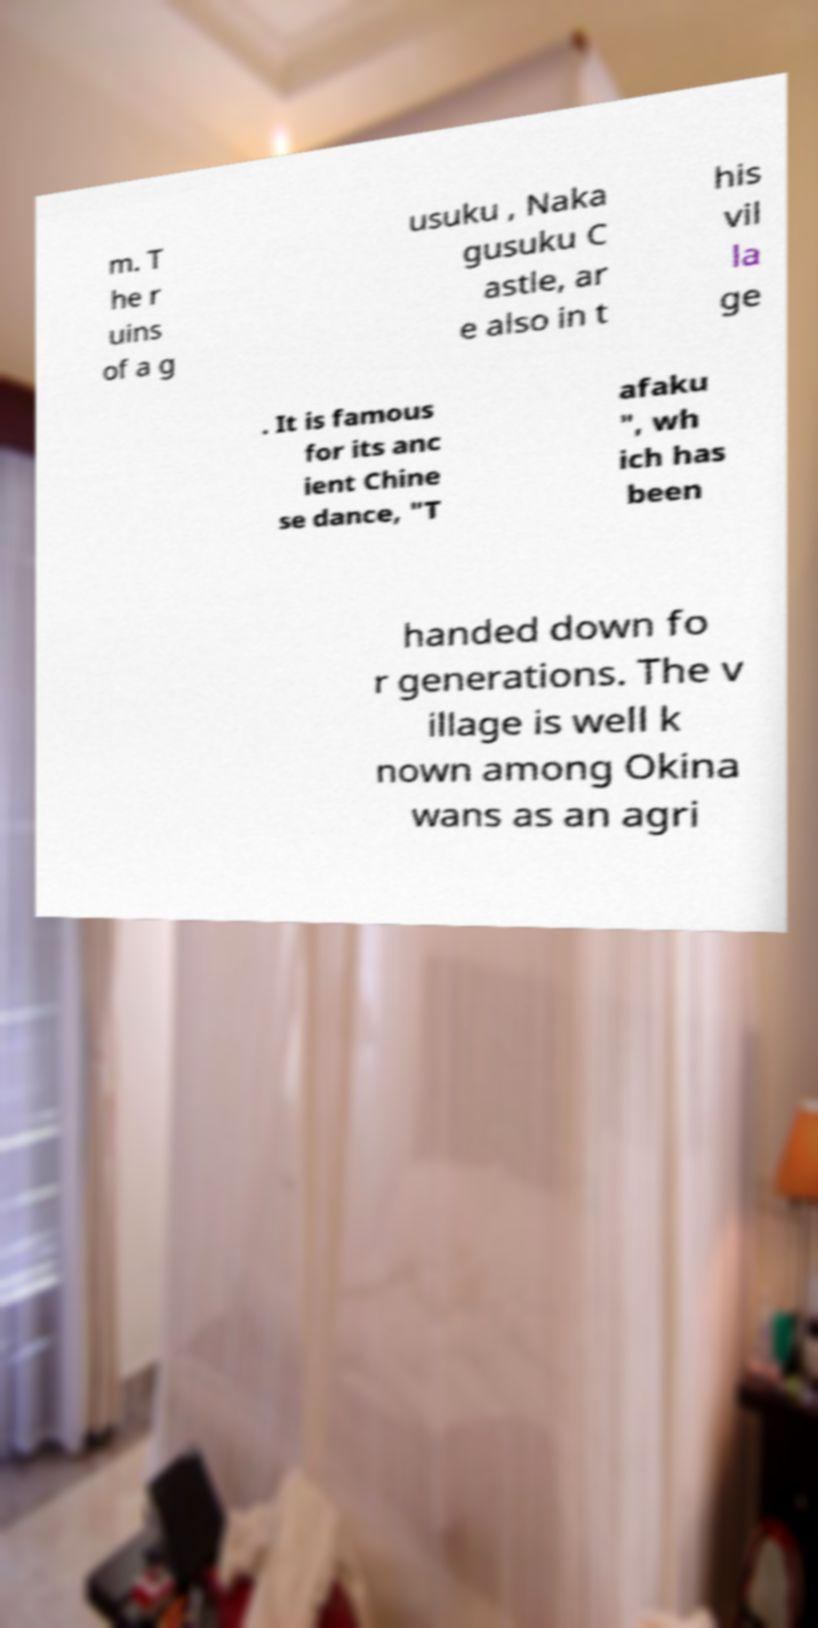Please read and relay the text visible in this image. What does it say? m. T he r uins of a g usuku , Naka gusuku C astle, ar e also in t his vil la ge . It is famous for its anc ient Chine se dance, "T afaku ", wh ich has been handed down fo r generations. The v illage is well k nown among Okina wans as an agri 